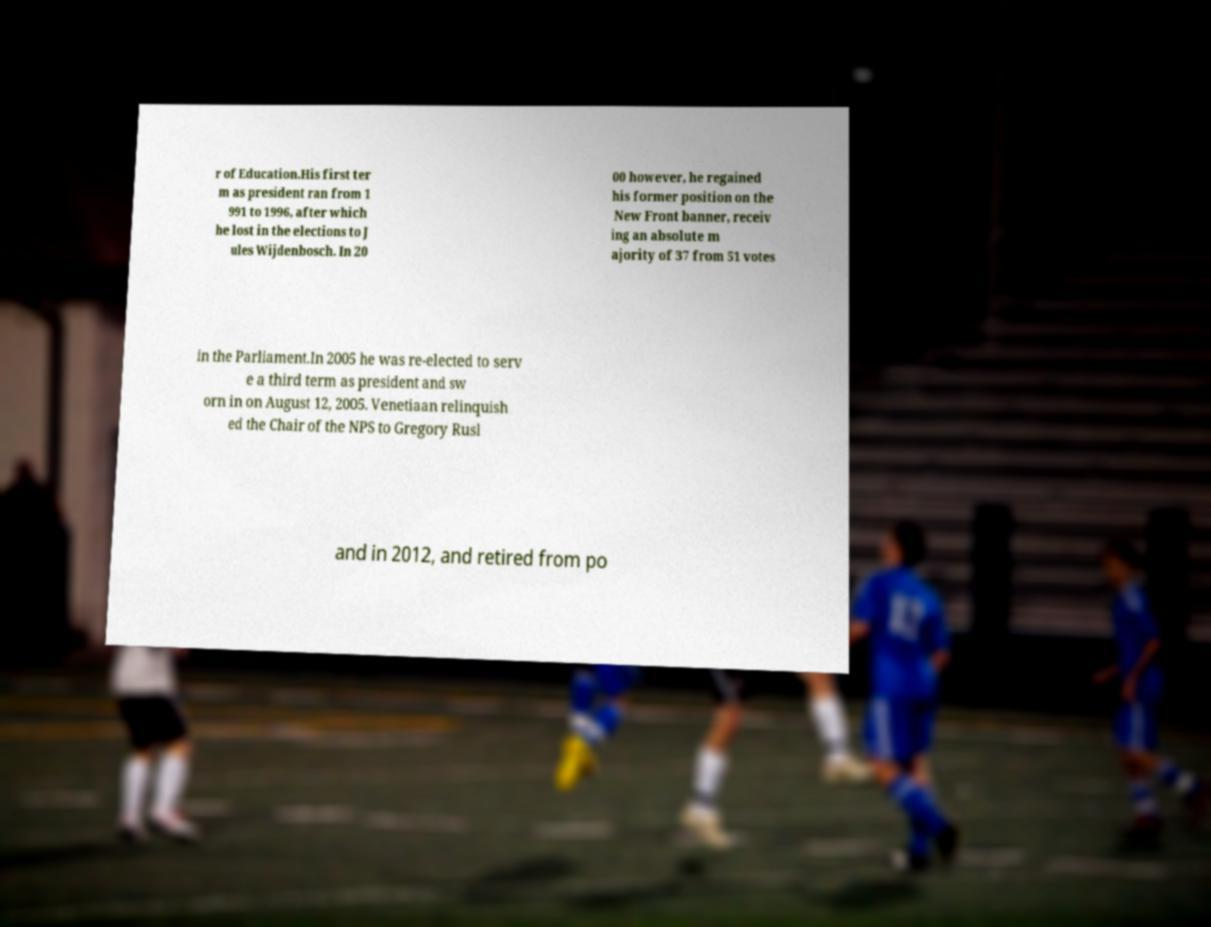Can you read and provide the text displayed in the image?This photo seems to have some interesting text. Can you extract and type it out for me? r of Education.His first ter m as president ran from 1 991 to 1996, after which he lost in the elections to J ules Wijdenbosch. In 20 00 however, he regained his former position on the New Front banner, receiv ing an absolute m ajority of 37 from 51 votes in the Parliament.In 2005 he was re-elected to serv e a third term as president and sw orn in on August 12, 2005. Venetiaan relinquish ed the Chair of the NPS to Gregory Rusl and in 2012, and retired from po 